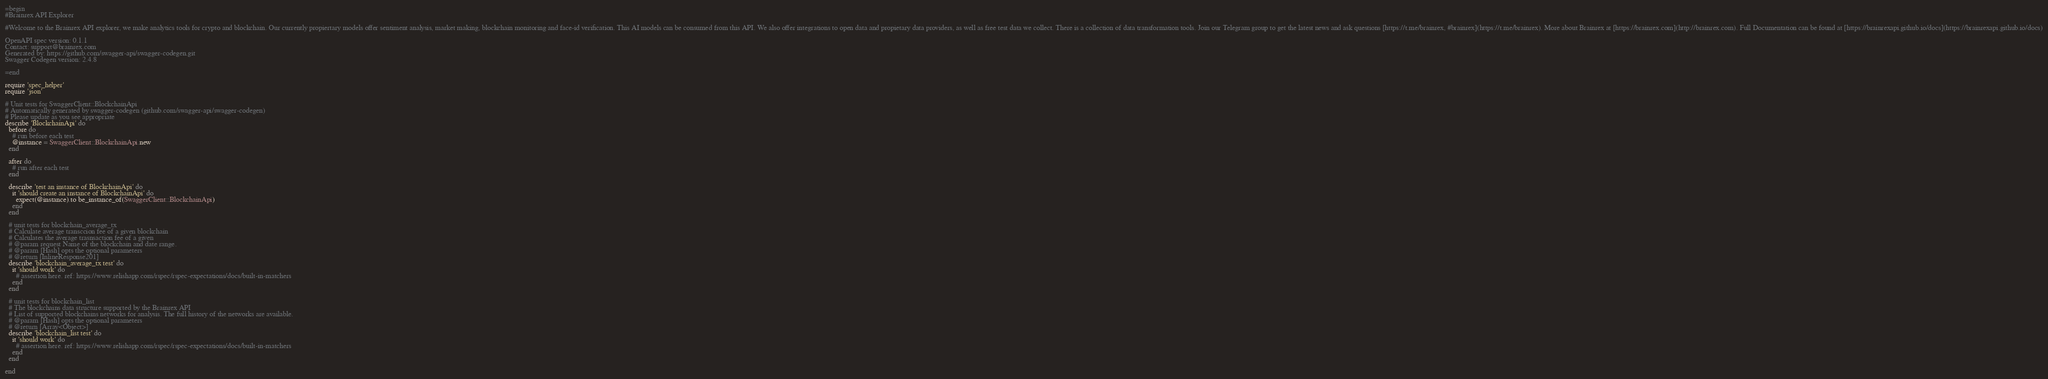<code> <loc_0><loc_0><loc_500><loc_500><_Ruby_>=begin
#Brainrex API Explorer

#Welcome to the Brainrex API explorer, we make analytics tools for crypto and blockchain. Our currently propiertary models offer sentiment analysis, market making, blockchain monitoring and face-id verification. This AI models can be consumed from this API. We also offer integrations to open data and propietary data providers, as well as free test data we collect. There is a collection of data transformation tools. Join our Telegram group to get the latest news and ask questions [https://t.me/brainrex, #brainrex](https://t.me/brainrex). More about Brainrex at [https://brainrex.com](http://brainrex.com). Full Documentation can be found at [https://brainrexapi.github.io/docs](https://brainrexapi.github.io/docs)

OpenAPI spec version: 0.1.1
Contact: support@brainrex.com
Generated by: https://github.com/swagger-api/swagger-codegen.git
Swagger Codegen version: 2.4.8

=end

require 'spec_helper'
require 'json'

# Unit tests for SwaggerClient::BlockchainApi
# Automatically generated by swagger-codegen (github.com/swagger-api/swagger-codegen)
# Please update as you see appropriate
describe 'BlockchainApi' do
  before do
    # run before each test
    @instance = SwaggerClient::BlockchainApi.new
  end

  after do
    # run after each test
  end

  describe 'test an instance of BlockchainApi' do
    it 'should create an instance of BlockchainApi' do
      expect(@instance).to be_instance_of(SwaggerClient::BlockchainApi)
    end
  end

  # unit tests for blockchain_average_tx
  # Calculate average transccion fee of a given blockchain
  # Calculates the average trasnsaction fee of a given 
  # @param request Name of the blockchain and date range.
  # @param [Hash] opts the optional parameters
  # @return [InlineResponse201]
  describe 'blockchain_average_tx test' do
    it 'should work' do
      # assertion here. ref: https://www.relishapp.com/rspec/rspec-expectations/docs/built-in-matchers
    end
  end

  # unit tests for blockchain_list
  # The blockchains data structure supported by the Brainrex API
  # List of supported blockchains networks for analysis. The full history of the networks are available.
  # @param [Hash] opts the optional parameters
  # @return [Array<Object>]
  describe 'blockchain_list test' do
    it 'should work' do
      # assertion here. ref: https://www.relishapp.com/rspec/rspec-expectations/docs/built-in-matchers
    end
  end

end
</code> 